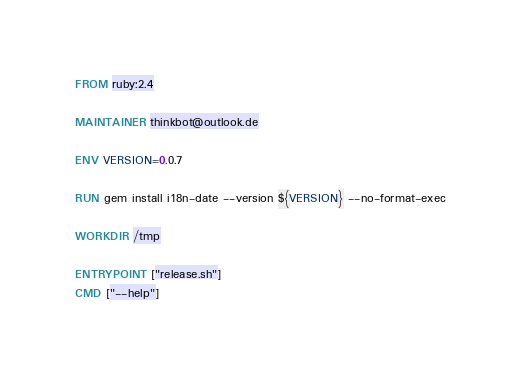<code> <loc_0><loc_0><loc_500><loc_500><_Dockerfile_>FROM ruby:2.4

MAINTAINER thinkbot@outlook.de

ENV VERSION=0.0.7

RUN gem install i18n-date --version ${VERSION} --no-format-exec

WORKDIR /tmp

ENTRYPOINT ["release.sh"]
CMD ["--help"]
</code> 